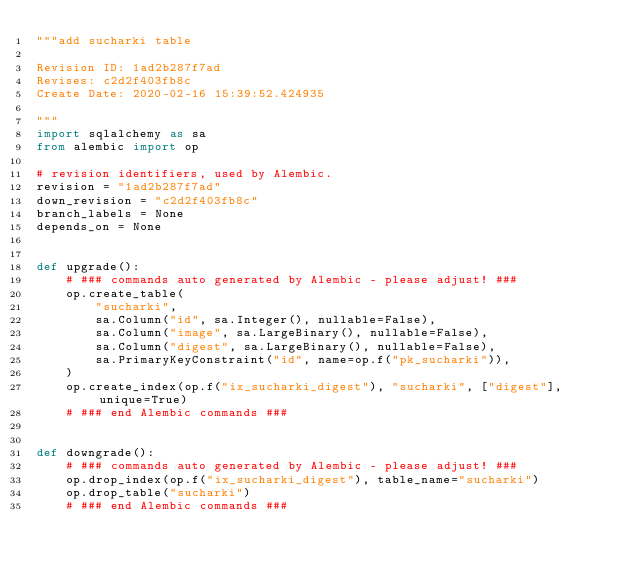<code> <loc_0><loc_0><loc_500><loc_500><_Python_>"""add sucharki table

Revision ID: 1ad2b287f7ad
Revises: c2d2f403fb8c
Create Date: 2020-02-16 15:39:52.424935

"""
import sqlalchemy as sa
from alembic import op

# revision identifiers, used by Alembic.
revision = "1ad2b287f7ad"
down_revision = "c2d2f403fb8c"
branch_labels = None
depends_on = None


def upgrade():
    # ### commands auto generated by Alembic - please adjust! ###
    op.create_table(
        "sucharki",
        sa.Column("id", sa.Integer(), nullable=False),
        sa.Column("image", sa.LargeBinary(), nullable=False),
        sa.Column("digest", sa.LargeBinary(), nullable=False),
        sa.PrimaryKeyConstraint("id", name=op.f("pk_sucharki")),
    )
    op.create_index(op.f("ix_sucharki_digest"), "sucharki", ["digest"], unique=True)
    # ### end Alembic commands ###


def downgrade():
    # ### commands auto generated by Alembic - please adjust! ###
    op.drop_index(op.f("ix_sucharki_digest"), table_name="sucharki")
    op.drop_table("sucharki")
    # ### end Alembic commands ###
</code> 